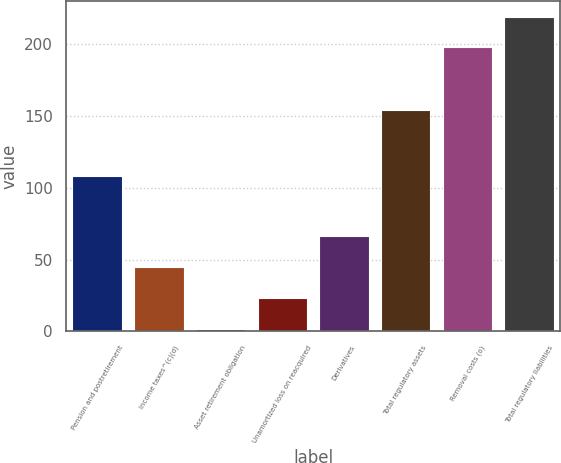<chart> <loc_0><loc_0><loc_500><loc_500><bar_chart><fcel>Pension and postretirement<fcel>Income taxes^(c)(d)<fcel>Asset retirement obligation<fcel>Unamortized loss on reacquired<fcel>Derivatives<fcel>Total regulatory assets<fcel>Removal costs (o)<fcel>Total regulatory liabilities<nl><fcel>108<fcel>44.8<fcel>2<fcel>23.4<fcel>66.2<fcel>154<fcel>198<fcel>219.4<nl></chart> 